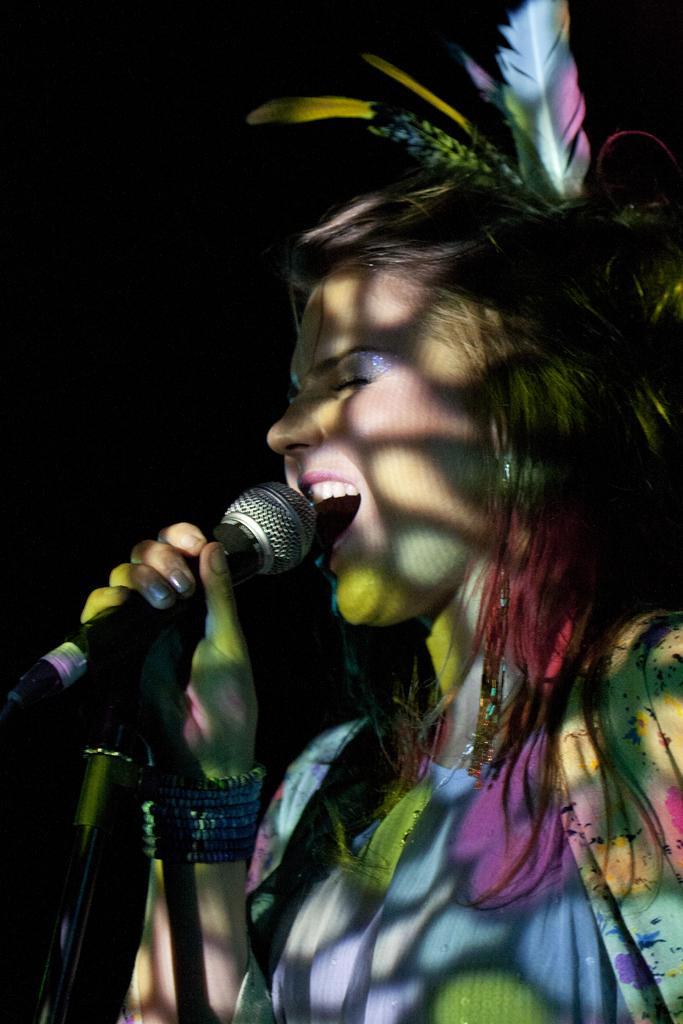Who is the main subject in the image? There is a girl in the image. What is the girl wearing? The girl is wearing a colorful dress. What is the girl holding in the image? The girl is holding a microphone. What is the girl doing in the image? The girl is singing a song. What is a noticeable accessory in the girl's hair? There is a feather in the girl's hair. What type of writer is visible in the image? There is no writer present in the image; it features a girl singing with a microphone. What kind of root can be seen growing from the girl's dress? There is no root visible in the image; the girl is wearing a dress with no roots mentioned. 